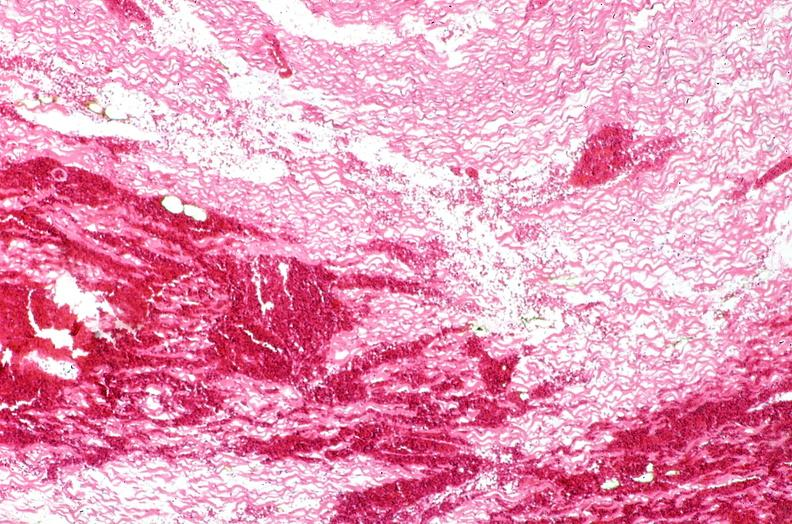does this image show heart, myocardial infarction, wavey fiber change, necrtosis, hemorrhage, and dissection?
Answer the question using a single word or phrase. Yes 